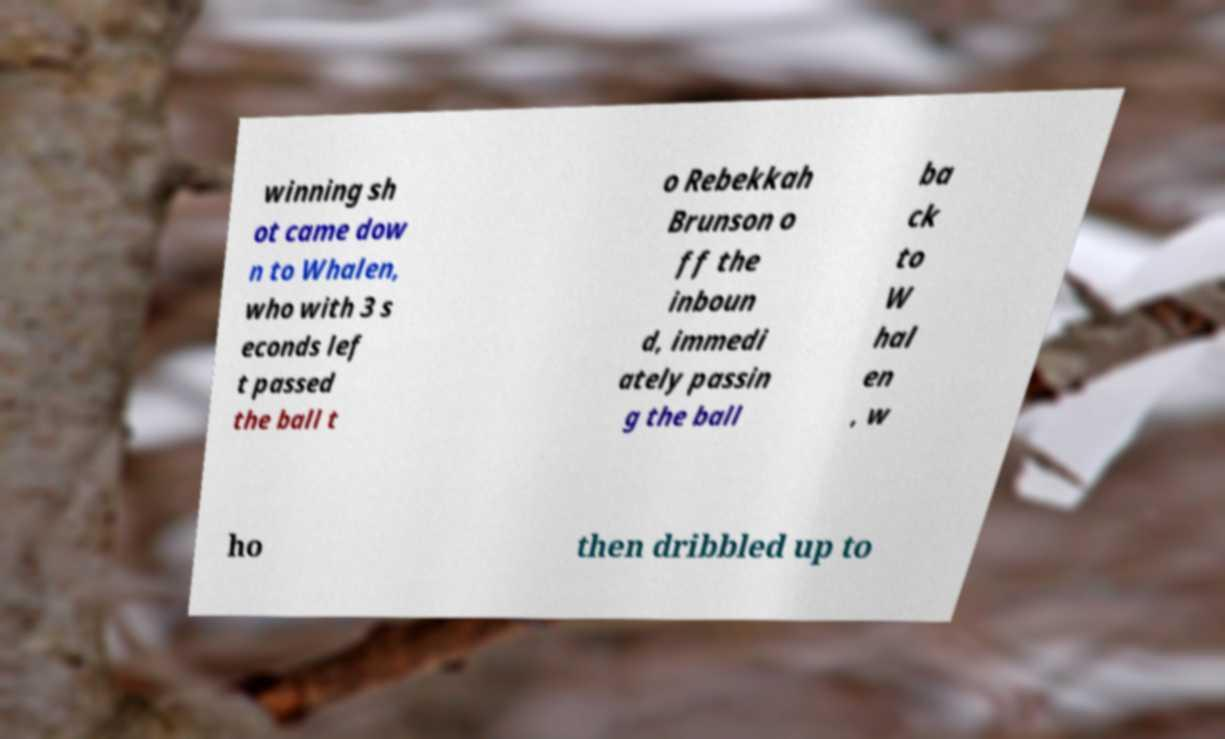Please identify and transcribe the text found in this image. winning sh ot came dow n to Whalen, who with 3 s econds lef t passed the ball t o Rebekkah Brunson o ff the inboun d, immedi ately passin g the ball ba ck to W hal en , w ho then dribbled up to 